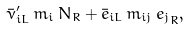<formula> <loc_0><loc_0><loc_500><loc_500>\bar { \nu } _ { i L } ^ { \prime } \, m _ { i } \, N _ { R } + \bar { e } _ { i L } \, m _ { i j } \, { e _ { j } } _ { R } ,</formula> 